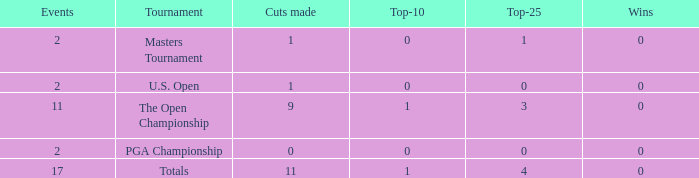What is his highest number of top 25s when eh played over 2 events and under 0 wins? None. 